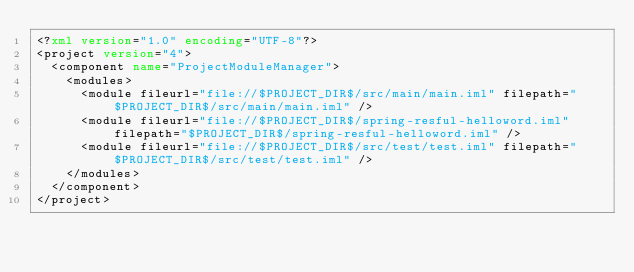<code> <loc_0><loc_0><loc_500><loc_500><_XML_><?xml version="1.0" encoding="UTF-8"?>
<project version="4">
  <component name="ProjectModuleManager">
    <modules>
      <module fileurl="file://$PROJECT_DIR$/src/main/main.iml" filepath="$PROJECT_DIR$/src/main/main.iml" />
      <module fileurl="file://$PROJECT_DIR$/spring-resful-helloword.iml" filepath="$PROJECT_DIR$/spring-resful-helloword.iml" />
      <module fileurl="file://$PROJECT_DIR$/src/test/test.iml" filepath="$PROJECT_DIR$/src/test/test.iml" />
    </modules>
  </component>
</project></code> 